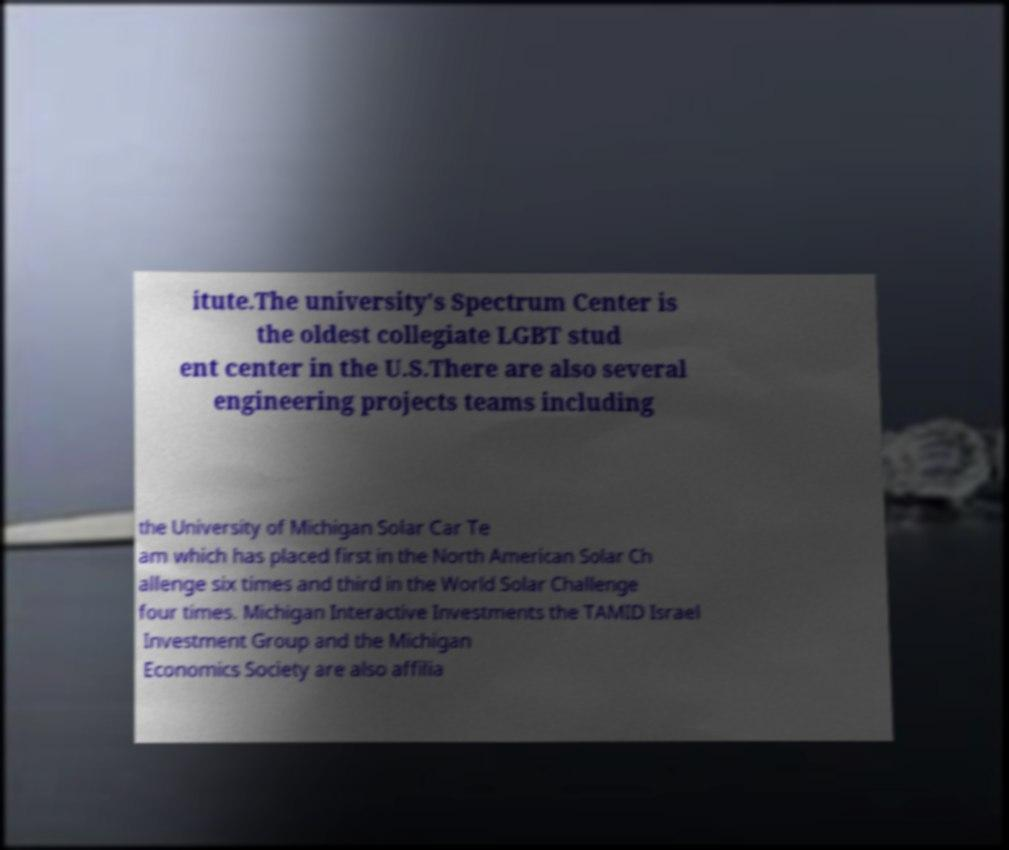Please read and relay the text visible in this image. What does it say? itute.The university's Spectrum Center is the oldest collegiate LGBT stud ent center in the U.S.There are also several engineering projects teams including the University of Michigan Solar Car Te am which has placed first in the North American Solar Ch allenge six times and third in the World Solar Challenge four times. Michigan Interactive Investments the TAMID Israel Investment Group and the Michigan Economics Society are also affilia 